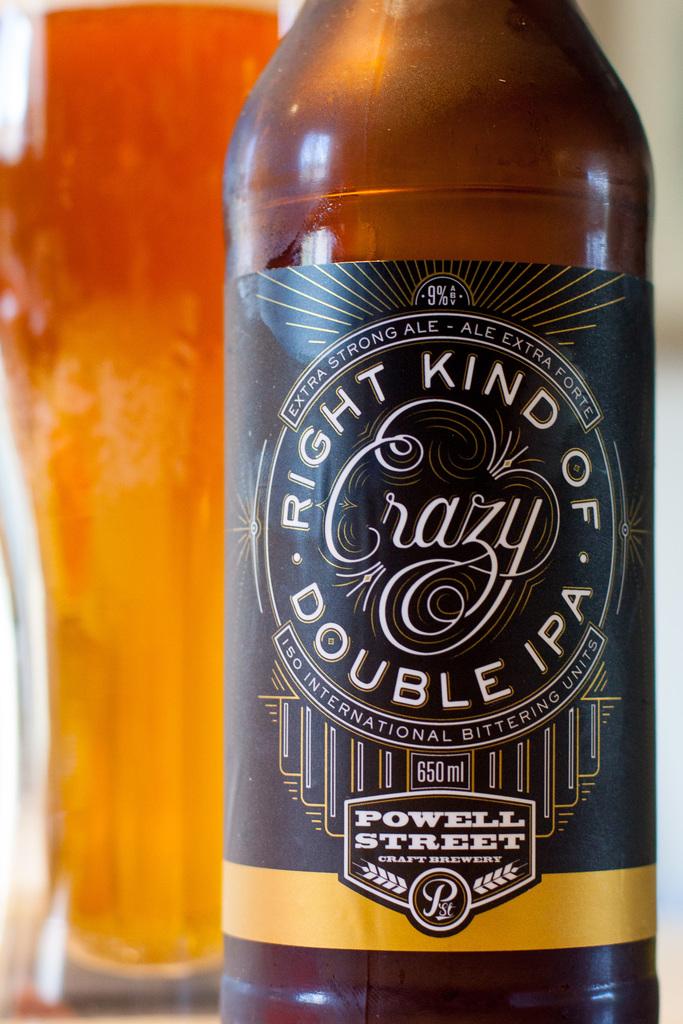What type of ipa is this?
Provide a short and direct response. Double. 